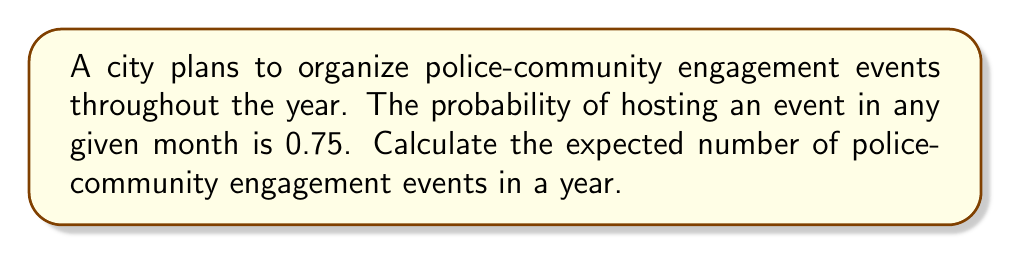Can you answer this question? To solve this problem, we'll use the concept of expected value. The expected value is calculated by multiplying the probability of an event occurring by the number of trials.

Step 1: Identify the given information
- Probability of an event in any month: $p = 0.75$
- Number of months in a year: $n = 12$

Step 2: Apply the formula for expected value
The expected value formula is:
$$E = n \times p$$

Where:
$E$ = Expected number of events
$n$ = Number of trials (months in this case)
$p$ = Probability of an event occurring

Step 3: Substitute the values and calculate
$$E = 12 \times 0.75 = 9$$

Therefore, the expected number of police-community engagement events in a year is 9.
Answer: 9 events 